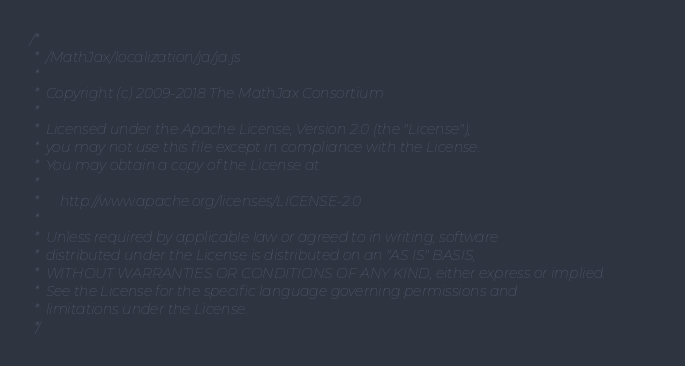<code> <loc_0><loc_0><loc_500><loc_500><_JavaScript_>/*
 *  /MathJax/localization/ja/ja.js
 *
 *  Copyright (c) 2009-2018 The MathJax Consortium
 *
 *  Licensed under the Apache License, Version 2.0 (the "License");
 *  you may not use this file except in compliance with the License.
 *  You may obtain a copy of the License at
 *
 *      http://www.apache.org/licenses/LICENSE-2.0
 *
 *  Unless required by applicable law or agreed to in writing, software
 *  distributed under the License is distributed on an "AS IS" BASIS,
 *  WITHOUT WARRANTIES OR CONDITIONS OF ANY KIND, either express or implied.
 *  See the License for the specific language governing permissions and
 *  limitations under the License.
 */
</code> 